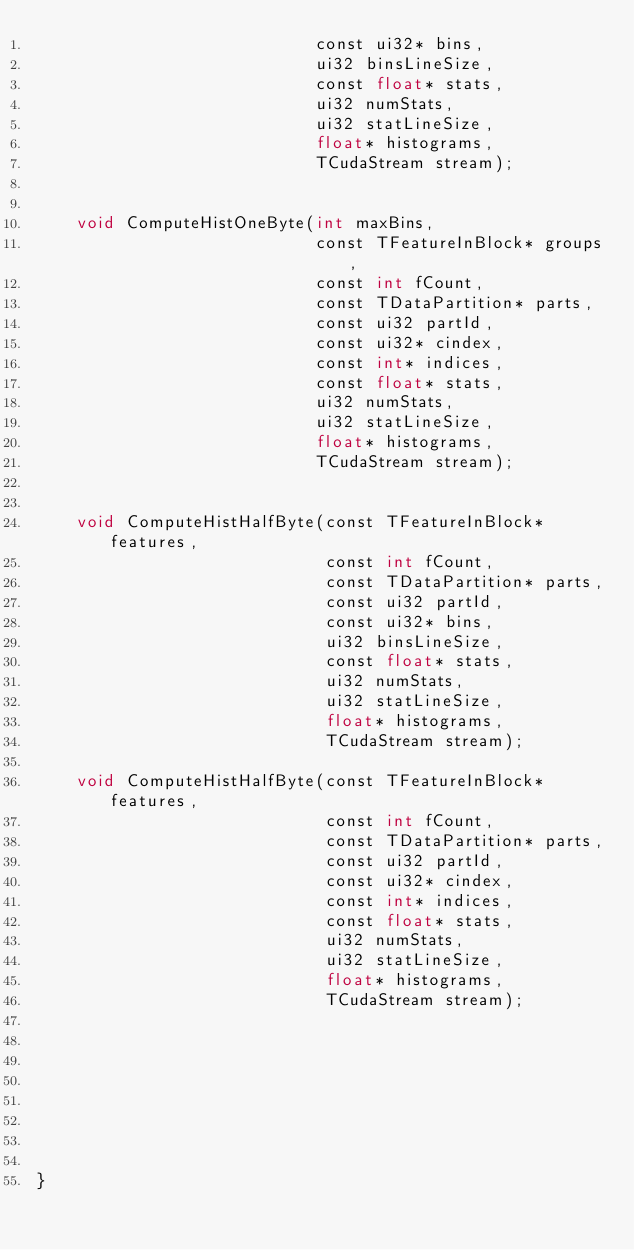Convert code to text. <code><loc_0><loc_0><loc_500><loc_500><_Cuda_>                            const ui32* bins,
                            ui32 binsLineSize,
                            const float* stats,
                            ui32 numStats,
                            ui32 statLineSize,
                            float* histograms,
                            TCudaStream stream);


    void ComputeHistOneByte(int maxBins,
                            const TFeatureInBlock* groups,
                            const int fCount,
                            const TDataPartition* parts,
                            const ui32 partId,
                            const ui32* cindex,
                            const int* indices,
                            const float* stats,
                            ui32 numStats,
                            ui32 statLineSize,
                            float* histograms,
                            TCudaStream stream);


    void ComputeHistHalfByte(const TFeatureInBlock* features,
                             const int fCount,
                             const TDataPartition* parts,
                             const ui32 partId,
                             const ui32* bins,
                             ui32 binsLineSize,
                             const float* stats,
                             ui32 numStats,
                             ui32 statLineSize,
                             float* histograms,
                             TCudaStream stream);

    void ComputeHistHalfByte(const TFeatureInBlock* features,
                             const int fCount,
                             const TDataPartition* parts,
                             const ui32 partId,
                             const ui32* cindex,
                             const int* indices,
                             const float* stats,
                             ui32 numStats,
                             ui32 statLineSize,
                             float* histograms,
                             TCudaStream stream);








}
</code> 